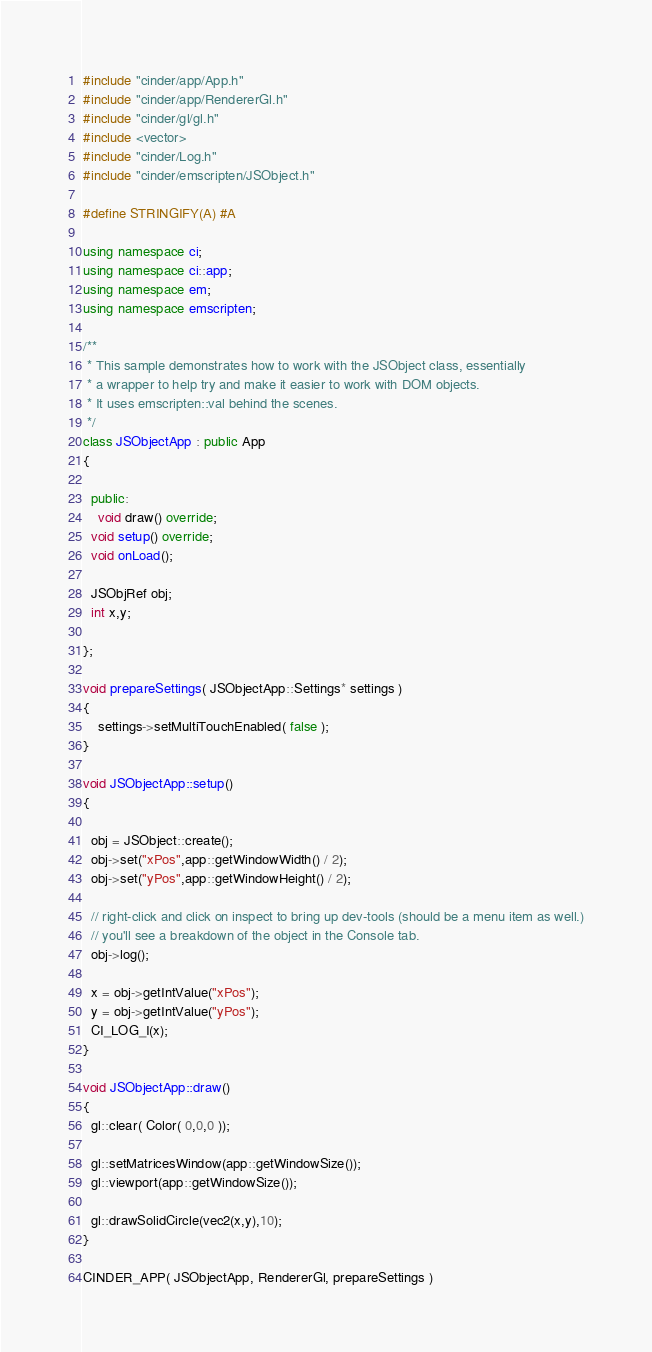Convert code to text. <code><loc_0><loc_0><loc_500><loc_500><_C++_>#include "cinder/app/App.h"
#include "cinder/app/RendererGl.h"
#include "cinder/gl/gl.h"
#include <vector>
#include "cinder/Log.h"
#include "cinder/emscripten/JSObject.h"

#define STRINGIFY(A) #A

using namespace ci;
using namespace ci::app;
using namespace em;
using namespace emscripten;

/**
 * This sample demonstrates how to work with the JSObject class, essentially 
 * a wrapper to help try and make it easier to work with DOM objects. 
 * It uses emscripten::val behind the scenes. 
 */
class JSObjectApp : public App 
{

  public:
	void draw() override;
  void setup() override;
  void onLoad();

  JSObjRef obj;
  int x,y;

};

void prepareSettings( JSObjectApp::Settings* settings )
{
	settings->setMultiTouchEnabled( false );
}

void JSObjectApp::setup()
{

  obj = JSObject::create();
  obj->set("xPos",app::getWindowWidth() / 2);
  obj->set("yPos",app::getWindowHeight() / 2);

  // right-click and click on inspect to bring up dev-tools (should be a menu item as well.)
  // you'll see a breakdown of the object in the Console tab.
  obj->log();

  x = obj->getIntValue("xPos");
  y = obj->getIntValue("yPos");
  CI_LOG_I(x);
}

void JSObjectApp::draw()
{
  gl::clear( Color( 0,0,0 ));

  gl::setMatricesWindow(app::getWindowSize());
  gl::viewport(app::getWindowSize());

  gl::drawSolidCircle(vec2(x,y),10);
}

CINDER_APP( JSObjectApp, RendererGl, prepareSettings )
</code> 